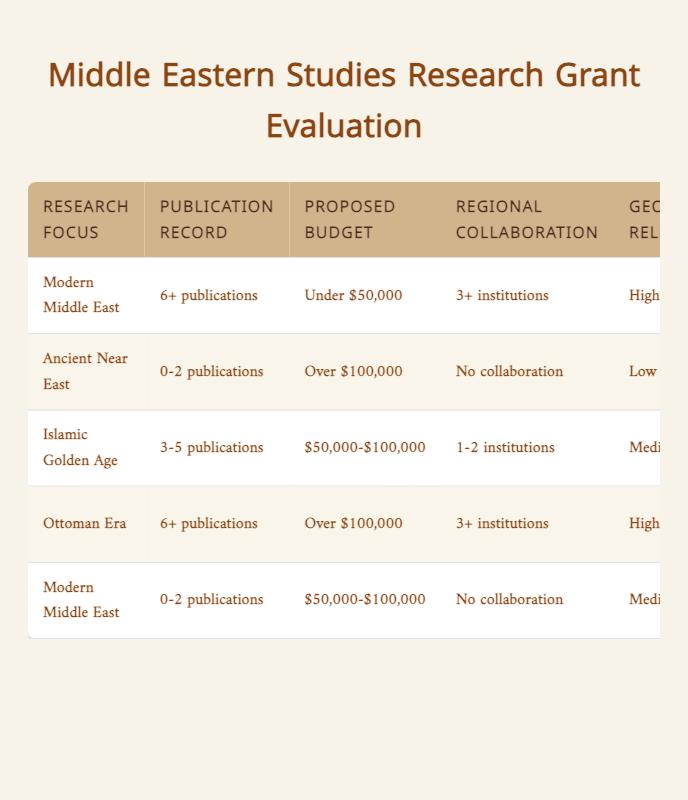What is the funding decision for research on the Modern Middle East with a high relevance to current geopolitical issues? According to the table, if the research focus is on the Modern Middle East, has 6+ publications, a proposed budget under $50,000, collaboration with 3+ institutions, and is highly relevant to current geopolitical issues, the funding decision is "Fully Approve".
Answer: Fully Approve How many reviewers are required for research focused on the Ottoman Era with a publication record of 6+ publications? The table indicates that for research on the Ottoman Era with 6+ publications and a proposed budget over $100,000, 3+ reviewers are required.
Answer: 3+ Reviewers Is collaboration with regional institutions necessary for the research proposal on the Ancient Near East? Based on the table, if the findings of the proposal show no collaboration with regional institutions regarding the Ancient Near East, the funding decision is to "Reject". Thus, collaboration is not necessary.
Answer: No What is the recommended funding amount for research in the Islamic Golden Age with a budget between $50,000 and $100,000? The entry for the Islamic Golden Age specifies that if the applicant has 3-5 publications with a proposed budget of $50,000-$100,000 and collaboration with 1-2 institutions, the recommended funding amount is "Up to $50,000".
Answer: Up to $50,000 Identify the research focus that receives a funding decision of "Reject". The table shows that the Ancient Near East is the research focus that receives a funding decision of "Reject", primarily due to a publication record of 0-2 publications, a proposed budget over $100,000, no collaboration, and low relevance to geopolitical issues.
Answer: Ancient Near East What is the average proposed budget among the research focuses that were fully approved? There are two research focuses that were fully approved: Modern Middle East with a budget under $50,000 and Ottoman Era with a budget over $100,000. Converting these budgets to numerical values for averaging: under $50,000 is approximately $25,000, and over $100,000 is approximately $100,000. The average is (25,000 + 100,000)/2 = 62,500.
Answer: $62,500 Does the research on the Modern Middle East with no publications require peer review? The table indicates that for Modern Middle East research with 0-2 publications, the funding decision is "Request Revisions," and it specifically requires "1 Reviewer" for peer review.
Answer: Yes What actions are required for the research on the Modern Middle East with high geopolitical relevance? For this research, actions include "Fully Approve" funding decision, recommending "Up to $50,000" funding amount, requiring "2 Reviewers" for peer review, and "Conference Call" for advisory board consultation. All actions denote a rule for higher research relevance leading to favorable decisions.
Answer: Fully Approve, Up to $50,000, 2 Reviewers, Conference Call 